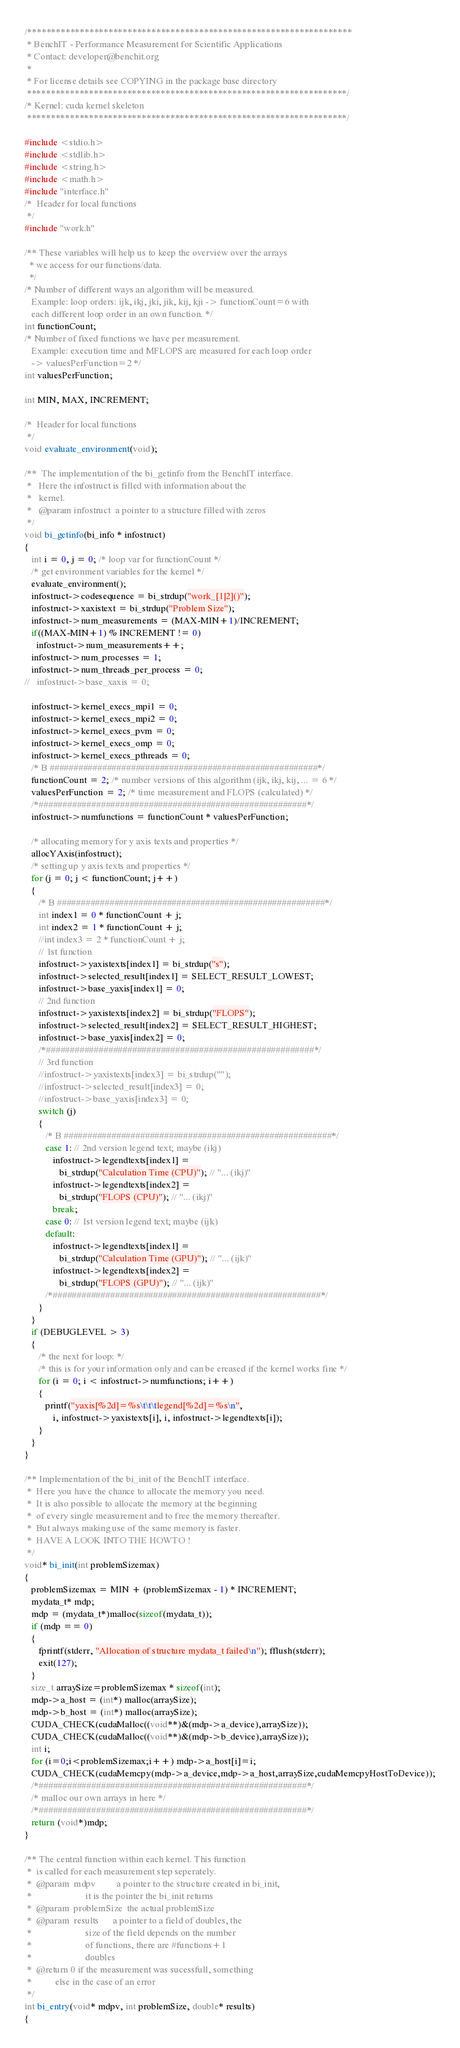Convert code to text. <code><loc_0><loc_0><loc_500><loc_500><_Cuda_>/********************************************************************
 * BenchIT - Performance Measurement for Scientific Applications
 * Contact: developer@benchit.org
 *
 * For license details see COPYING in the package base directory
 *******************************************************************/
/* Kernel: cuda kernel skeleton
 *******************************************************************/

#include <stdio.h>
#include <stdlib.h>
#include <string.h>
#include <math.h>
#include "interface.h"
/*  Header for local functions
 */
#include "work.h"

/** These variables will help us to keep the overview over the arrays
  * we access for our functions/data.
  */
/* Number of different ways an algorithm will be measured.
   Example: loop orders: ijk, ikj, jki, jik, kij, kji -> functionCount=6 with
   each different loop order in an own function. */
int functionCount;
/* Number of fixed functions we have per measurement.
   Example: execution time and MFLOPS are measured for each loop order
   -> valuesPerFunction=2 */
int valuesPerFunction;

int MIN, MAX, INCREMENT;

/*  Header for local functions
 */
void evaluate_environment(void);

/**  The implementation of the bi_getinfo from the BenchIT interface.
 *   Here the infostruct is filled with information about the
 *   kernel.
 *   @param infostruct  a pointer to a structure filled with zeros
 */
void bi_getinfo(bi_info * infostruct)
{
   int i = 0, j = 0; /* loop var for functionCount */
   /* get environment variables for the kernel */
   evaluate_environment();
   infostruct->codesequence = bi_strdup("work_[1|2]()");
   infostruct->xaxistext = bi_strdup("Problem Size");
   infostruct->num_measurements = (MAX-MIN+1)/INCREMENT;
   if((MAX-MIN+1) % INCREMENT != 0)
     infostruct->num_measurements++;
   infostruct->num_processes = 1;
   infostruct->num_threads_per_process = 0;
//   infostruct->base_xaxis = 0;

   infostruct->kernel_execs_mpi1 = 0;
   infostruct->kernel_execs_mpi2 = 0;
   infostruct->kernel_execs_pvm = 0;
   infostruct->kernel_execs_omp = 0;
   infostruct->kernel_execs_pthreads = 0;
   /* B ########################################################*/
   functionCount = 2; /* number versions of this algorithm (ijk, ikj, kij, ... = 6 */
   valuesPerFunction = 2; /* time measurement and FLOPS (calculated) */
   /*########################################################*/
   infostruct->numfunctions = functionCount * valuesPerFunction;

   /* allocating memory for y axis texts and properties */
   allocYAxis(infostruct);
   /* setting up y axis texts and properties */
   for (j = 0; j < functionCount; j++)
   {
      /* B ########################################################*/
      int index1 = 0 * functionCount + j;
      int index2 = 1 * functionCount + j;
      //int index3 = 2 * functionCount + j;
      // 1st function
      infostruct->yaxistexts[index1] = bi_strdup("s");
      infostruct->selected_result[index1] = SELECT_RESULT_LOWEST;
      infostruct->base_yaxis[index1] = 0;
      // 2nd function
      infostruct->yaxistexts[index2] = bi_strdup("FLOPS");
      infostruct->selected_result[index2] = SELECT_RESULT_HIGHEST;
      infostruct->base_yaxis[index2] = 0;
      /*########################################################*/
      // 3rd function
      //infostruct->yaxistexts[index3] = bi_strdup("");
      //infostruct->selected_result[index3] = 0;
      //infostruct->base_yaxis[index3] = 0;
      switch (j)
      {
         /* B ########################################################*/
         case 1: // 2nd version legend text; maybe (ikj)
            infostruct->legendtexts[index1] =
               bi_strdup("Calculation Time (CPU)"); // "... (ikj)"
            infostruct->legendtexts[index2] =
               bi_strdup("FLOPS (CPU)"); // "... (ikj)"
            break;
         case 0: // 1st version legend text; maybe (ijk)
         default:
            infostruct->legendtexts[index1] =
               bi_strdup("Calculation Time (GPU)"); // "... (ijk)"
            infostruct->legendtexts[index2] =
               bi_strdup("FLOPS (GPU)"); // "... (ijk)"
         /*########################################################*/
      }
   }
   if (DEBUGLEVEL > 3)
   {
      /* the next for loop: */
      /* this is for your information only and can be ereased if the kernel works fine */
      for (i = 0; i < infostruct->numfunctions; i++)
      {
         printf("yaxis[%2d]=%s\t\t\tlegend[%2d]=%s\n",
            i, infostruct->yaxistexts[i], i, infostruct->legendtexts[i]);
      }
   }
}

/** Implementation of the bi_init of the BenchIT interface.
 *  Here you have the chance to allocate the memory you need.
 *  It is also possible to allocate the memory at the beginning
 *  of every single measurement and to free the memory thereafter.
 *  But always making use of the same memory is faster.
 *  HAVE A LOOK INTO THE HOWTO !
 */
void* bi_init(int problemSizemax)
{
   problemSizemax = MIN + (problemSizemax - 1) * INCREMENT;
   mydata_t* mdp;
   mdp = (mydata_t*)malloc(sizeof(mydata_t));
   if (mdp == 0)
   {
      fprintf(stderr, "Allocation of structure mydata_t failed\n"); fflush(stderr);
      exit(127);
   }
   size_t arraySize=problemSizemax * sizeof(int);
   mdp->a_host = (int*) malloc(arraySize);
   mdp->b_host = (int*) malloc(arraySize);
   CUDA_CHECK(cudaMalloc((void**)&(mdp->a_device),arraySize));
   CUDA_CHECK(cudaMalloc((void**)&(mdp->b_device),arraySize));
   int i;
   for (i=0;i<problemSizemax;i++) mdp->a_host[i]=i;
   CUDA_CHECK(cudaMemcpy(mdp->a_device,mdp->a_host,arraySize,cudaMemcpyHostToDevice));
   /*########################################################*/
   /* malloc our own arrays in here */
   /*########################################################*/
   return (void*)mdp;
}

/** The central function within each kernel. This function
 *  is called for each measurement step seperately.
 *  @param  mdpv         a pointer to the structure created in bi_init,
 *                       it is the pointer the bi_init returns
 *  @param  problemSize  the actual problemSize
 *  @param  results      a pointer to a field of doubles, the
 *                       size of the field depends on the number
 *                       of functions, there are #functions+1
 *                       doubles
 *  @return 0 if the measurement was sucessfull, something
 *          else in the case of an error
 */
int bi_entry(void* mdpv, int problemSize, double* results)
{</code> 